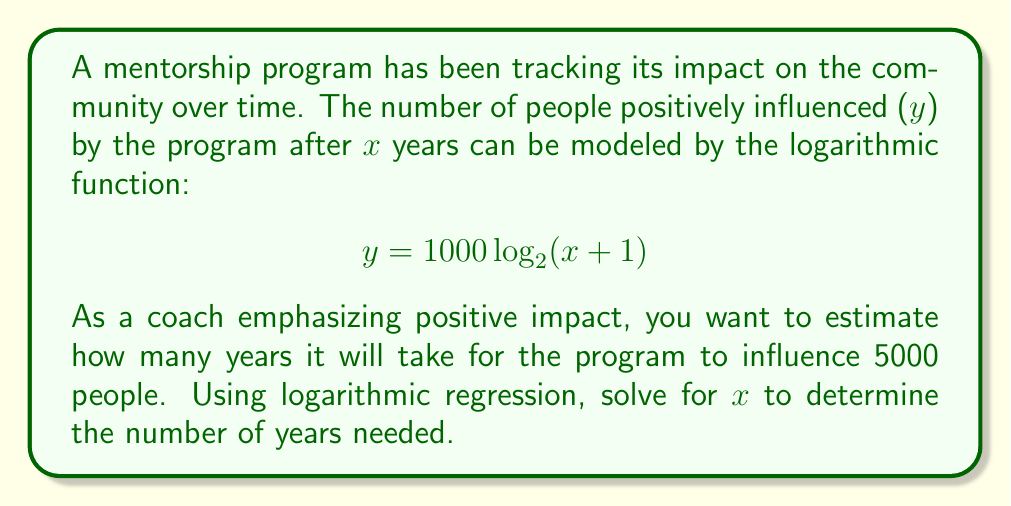Can you solve this math problem? To solve this problem, we'll follow these steps:

1) We're given the equation: $y = 1000 \log_2(x + 1)$
   We want to find x when y = 5000

2) Substitute y = 5000 into the equation:
   $5000 = 1000 \log_2(x + 1)$

3) Divide both sides by 1000:
   $5 = \log_2(x + 1)$

4) To solve for x, we need to apply the inverse function (exponential) to both sides:
   $2^5 = x + 1$

5) Simplify the left side:
   $32 = x + 1$

6) Subtract 1 from both sides:
   $31 = x$

Therefore, it will take approximately 31 years for the mentorship program to influence 5000 people.
Answer: 31 years 